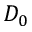Convert formula to latex. <formula><loc_0><loc_0><loc_500><loc_500>D _ { 0 }</formula> 